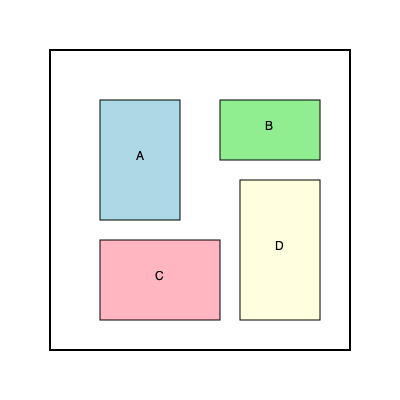As a supportive manager, you want to optimize the mail carrier's delivery bag space. The diagram shows four different types of mail items (A, B, C, and D) that need to be packed into the delivery bag. If the bag can only fit items side by side without stacking, what is the minimum number of 90-degree rotations needed to fit all items into the bag? To solve this problem, we need to consider the dimensions of each item and how they can be arranged to fit within the bag's space. Let's approach this step-by-step:

1. Analyze the current orientation of items:
   A: 80 x 120
   B: 100 x 60
   C: 120 x 80
   D: 80 x 140

2. The bag's dimensions are 300 x 300.

3. Current total width: 80 + 100 + 120 + 80 = 380 > 300
   Current total height: 120 + 60 + 80 + 140 = 400 > 300

4. We need to rotate some items to reduce either the total width or height:

   - Rotate B 90 degrees: 60 x 100
   - Rotate C 90 degrees: 80 x 120
   - Keep A and D as they are

5. New arrangement:
   A: 80 x 120
   B (rotated): 60 x 100
   C (rotated): 80 x 120
   D: 80 x 140

6. New total width: 80 + 60 + 80 + 80 = 300
   New total height: 140 (maximum height of D)

7. This arrangement fits within the 300 x 300 bag dimensions.

8. We performed 2 rotations (B and C) to achieve this fit.

Therefore, the minimum number of 90-degree rotations needed is 2.
Answer: 2 rotations 